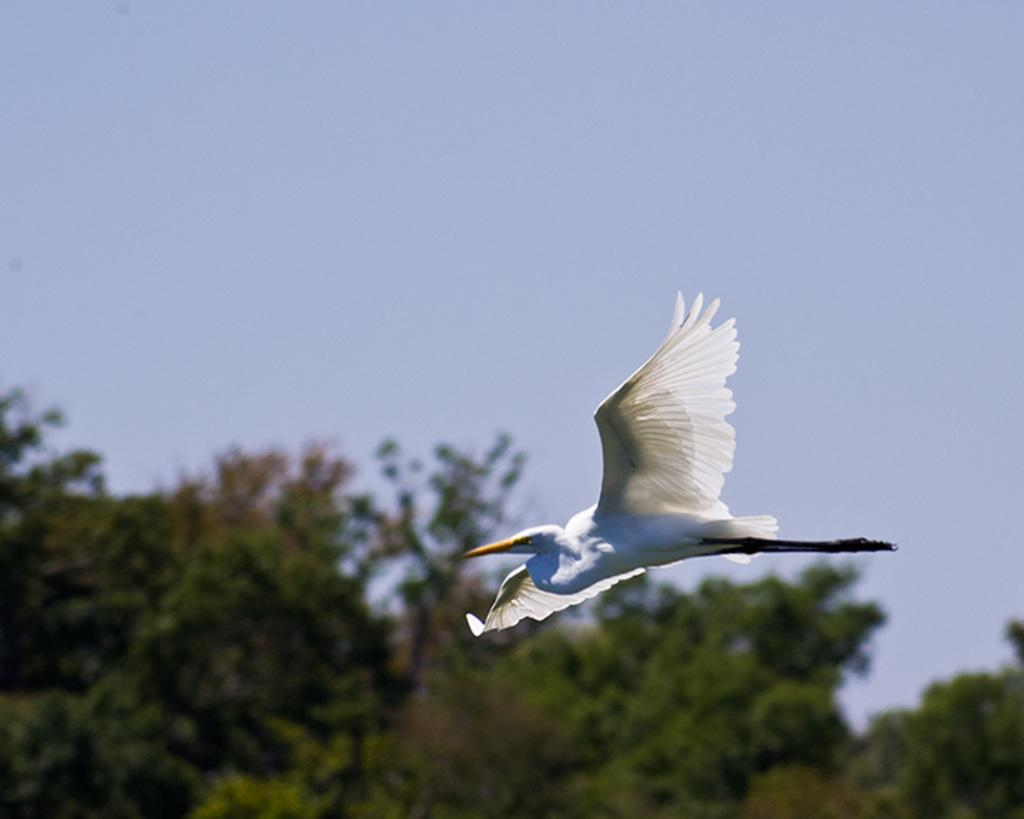What is the main subject of the image? The main subject of the image is a bird flying. What can be seen in the background of the image? There are trees and the sky visible in the background of the image. What type of toy can be seen in the bird's beak in the image? There is no toy present in the image; it features a bird flying with no objects in its beak. 